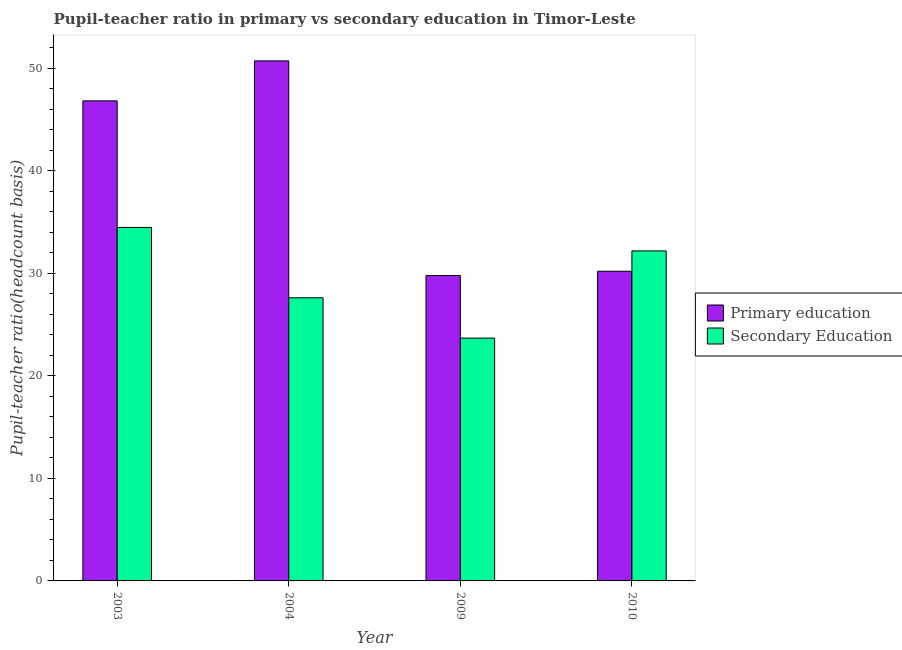How many groups of bars are there?
Ensure brevity in your answer.  4. How many bars are there on the 1st tick from the right?
Provide a short and direct response. 2. What is the pupil-teacher ratio in primary education in 2009?
Your response must be concise. 29.78. Across all years, what is the maximum pupil teacher ratio on secondary education?
Provide a succinct answer. 34.47. Across all years, what is the minimum pupil-teacher ratio in primary education?
Your answer should be compact. 29.78. In which year was the pupil-teacher ratio in primary education maximum?
Make the answer very short. 2004. What is the total pupil teacher ratio on secondary education in the graph?
Offer a very short reply. 117.94. What is the difference between the pupil-teacher ratio in primary education in 2003 and that in 2009?
Offer a very short reply. 17.04. What is the difference between the pupil teacher ratio on secondary education in 2010 and the pupil-teacher ratio in primary education in 2004?
Keep it short and to the point. 4.57. What is the average pupil teacher ratio on secondary education per year?
Offer a very short reply. 29.49. In the year 2004, what is the difference between the pupil-teacher ratio in primary education and pupil teacher ratio on secondary education?
Provide a short and direct response. 0. In how many years, is the pupil-teacher ratio in primary education greater than 24?
Your answer should be very brief. 4. What is the ratio of the pupil-teacher ratio in primary education in 2004 to that in 2010?
Your answer should be very brief. 1.68. Is the pupil teacher ratio on secondary education in 2009 less than that in 2010?
Provide a short and direct response. Yes. Is the difference between the pupil-teacher ratio in primary education in 2004 and 2009 greater than the difference between the pupil teacher ratio on secondary education in 2004 and 2009?
Make the answer very short. No. What is the difference between the highest and the second highest pupil teacher ratio on secondary education?
Make the answer very short. 2.29. What is the difference between the highest and the lowest pupil-teacher ratio in primary education?
Ensure brevity in your answer.  20.94. Is the sum of the pupil teacher ratio on secondary education in 2004 and 2009 greater than the maximum pupil-teacher ratio in primary education across all years?
Provide a succinct answer. Yes. What does the 2nd bar from the left in 2003 represents?
Provide a short and direct response. Secondary Education. What does the 1st bar from the right in 2003 represents?
Make the answer very short. Secondary Education. Are all the bars in the graph horizontal?
Ensure brevity in your answer.  No. How many years are there in the graph?
Your response must be concise. 4. What is the difference between two consecutive major ticks on the Y-axis?
Keep it short and to the point. 10. Does the graph contain any zero values?
Your answer should be very brief. No. Does the graph contain grids?
Give a very brief answer. No. What is the title of the graph?
Provide a short and direct response. Pupil-teacher ratio in primary vs secondary education in Timor-Leste. Does "Male entrants" appear as one of the legend labels in the graph?
Keep it short and to the point. No. What is the label or title of the X-axis?
Your response must be concise. Year. What is the label or title of the Y-axis?
Provide a short and direct response. Pupil-teacher ratio(headcount basis). What is the Pupil-teacher ratio(headcount basis) in Primary education in 2003?
Provide a succinct answer. 46.82. What is the Pupil-teacher ratio(headcount basis) in Secondary Education in 2003?
Provide a succinct answer. 34.47. What is the Pupil-teacher ratio(headcount basis) of Primary education in 2004?
Your response must be concise. 50.71. What is the Pupil-teacher ratio(headcount basis) in Secondary Education in 2004?
Give a very brief answer. 27.61. What is the Pupil-teacher ratio(headcount basis) of Primary education in 2009?
Offer a terse response. 29.78. What is the Pupil-teacher ratio(headcount basis) in Secondary Education in 2009?
Offer a terse response. 23.68. What is the Pupil-teacher ratio(headcount basis) of Primary education in 2010?
Your answer should be very brief. 30.2. What is the Pupil-teacher ratio(headcount basis) of Secondary Education in 2010?
Provide a succinct answer. 32.18. Across all years, what is the maximum Pupil-teacher ratio(headcount basis) of Primary education?
Your answer should be very brief. 50.71. Across all years, what is the maximum Pupil-teacher ratio(headcount basis) in Secondary Education?
Offer a terse response. 34.47. Across all years, what is the minimum Pupil-teacher ratio(headcount basis) of Primary education?
Your answer should be compact. 29.78. Across all years, what is the minimum Pupil-teacher ratio(headcount basis) in Secondary Education?
Your response must be concise. 23.68. What is the total Pupil-teacher ratio(headcount basis) of Primary education in the graph?
Your answer should be very brief. 157.51. What is the total Pupil-teacher ratio(headcount basis) of Secondary Education in the graph?
Keep it short and to the point. 117.94. What is the difference between the Pupil-teacher ratio(headcount basis) of Primary education in 2003 and that in 2004?
Your response must be concise. -3.9. What is the difference between the Pupil-teacher ratio(headcount basis) in Secondary Education in 2003 and that in 2004?
Keep it short and to the point. 6.86. What is the difference between the Pupil-teacher ratio(headcount basis) of Primary education in 2003 and that in 2009?
Keep it short and to the point. 17.04. What is the difference between the Pupil-teacher ratio(headcount basis) of Secondary Education in 2003 and that in 2009?
Offer a very short reply. 10.79. What is the difference between the Pupil-teacher ratio(headcount basis) in Primary education in 2003 and that in 2010?
Offer a terse response. 16.62. What is the difference between the Pupil-teacher ratio(headcount basis) of Secondary Education in 2003 and that in 2010?
Provide a short and direct response. 2.29. What is the difference between the Pupil-teacher ratio(headcount basis) of Primary education in 2004 and that in 2009?
Provide a succinct answer. 20.94. What is the difference between the Pupil-teacher ratio(headcount basis) of Secondary Education in 2004 and that in 2009?
Your answer should be compact. 3.93. What is the difference between the Pupil-teacher ratio(headcount basis) in Primary education in 2004 and that in 2010?
Your response must be concise. 20.52. What is the difference between the Pupil-teacher ratio(headcount basis) in Secondary Education in 2004 and that in 2010?
Make the answer very short. -4.57. What is the difference between the Pupil-teacher ratio(headcount basis) of Primary education in 2009 and that in 2010?
Offer a terse response. -0.42. What is the difference between the Pupil-teacher ratio(headcount basis) in Secondary Education in 2009 and that in 2010?
Provide a succinct answer. -8.51. What is the difference between the Pupil-teacher ratio(headcount basis) in Primary education in 2003 and the Pupil-teacher ratio(headcount basis) in Secondary Education in 2004?
Your response must be concise. 19.2. What is the difference between the Pupil-teacher ratio(headcount basis) in Primary education in 2003 and the Pupil-teacher ratio(headcount basis) in Secondary Education in 2009?
Ensure brevity in your answer.  23.14. What is the difference between the Pupil-teacher ratio(headcount basis) of Primary education in 2003 and the Pupil-teacher ratio(headcount basis) of Secondary Education in 2010?
Make the answer very short. 14.63. What is the difference between the Pupil-teacher ratio(headcount basis) in Primary education in 2004 and the Pupil-teacher ratio(headcount basis) in Secondary Education in 2009?
Offer a very short reply. 27.04. What is the difference between the Pupil-teacher ratio(headcount basis) in Primary education in 2004 and the Pupil-teacher ratio(headcount basis) in Secondary Education in 2010?
Offer a very short reply. 18.53. What is the difference between the Pupil-teacher ratio(headcount basis) in Primary education in 2009 and the Pupil-teacher ratio(headcount basis) in Secondary Education in 2010?
Ensure brevity in your answer.  -2.41. What is the average Pupil-teacher ratio(headcount basis) in Primary education per year?
Offer a very short reply. 39.38. What is the average Pupil-teacher ratio(headcount basis) in Secondary Education per year?
Your answer should be very brief. 29.49. In the year 2003, what is the difference between the Pupil-teacher ratio(headcount basis) of Primary education and Pupil-teacher ratio(headcount basis) of Secondary Education?
Your response must be concise. 12.34. In the year 2004, what is the difference between the Pupil-teacher ratio(headcount basis) in Primary education and Pupil-teacher ratio(headcount basis) in Secondary Education?
Ensure brevity in your answer.  23.1. In the year 2009, what is the difference between the Pupil-teacher ratio(headcount basis) in Primary education and Pupil-teacher ratio(headcount basis) in Secondary Education?
Provide a short and direct response. 6.1. In the year 2010, what is the difference between the Pupil-teacher ratio(headcount basis) in Primary education and Pupil-teacher ratio(headcount basis) in Secondary Education?
Your answer should be compact. -1.98. What is the ratio of the Pupil-teacher ratio(headcount basis) of Primary education in 2003 to that in 2004?
Keep it short and to the point. 0.92. What is the ratio of the Pupil-teacher ratio(headcount basis) in Secondary Education in 2003 to that in 2004?
Your answer should be very brief. 1.25. What is the ratio of the Pupil-teacher ratio(headcount basis) in Primary education in 2003 to that in 2009?
Offer a very short reply. 1.57. What is the ratio of the Pupil-teacher ratio(headcount basis) of Secondary Education in 2003 to that in 2009?
Your answer should be very brief. 1.46. What is the ratio of the Pupil-teacher ratio(headcount basis) of Primary education in 2003 to that in 2010?
Offer a very short reply. 1.55. What is the ratio of the Pupil-teacher ratio(headcount basis) in Secondary Education in 2003 to that in 2010?
Your response must be concise. 1.07. What is the ratio of the Pupil-teacher ratio(headcount basis) in Primary education in 2004 to that in 2009?
Offer a very short reply. 1.7. What is the ratio of the Pupil-teacher ratio(headcount basis) in Secondary Education in 2004 to that in 2009?
Ensure brevity in your answer.  1.17. What is the ratio of the Pupil-teacher ratio(headcount basis) of Primary education in 2004 to that in 2010?
Provide a short and direct response. 1.68. What is the ratio of the Pupil-teacher ratio(headcount basis) of Secondary Education in 2004 to that in 2010?
Keep it short and to the point. 0.86. What is the ratio of the Pupil-teacher ratio(headcount basis) in Primary education in 2009 to that in 2010?
Your answer should be compact. 0.99. What is the ratio of the Pupil-teacher ratio(headcount basis) in Secondary Education in 2009 to that in 2010?
Make the answer very short. 0.74. What is the difference between the highest and the second highest Pupil-teacher ratio(headcount basis) of Primary education?
Provide a short and direct response. 3.9. What is the difference between the highest and the second highest Pupil-teacher ratio(headcount basis) in Secondary Education?
Keep it short and to the point. 2.29. What is the difference between the highest and the lowest Pupil-teacher ratio(headcount basis) of Primary education?
Your answer should be compact. 20.94. What is the difference between the highest and the lowest Pupil-teacher ratio(headcount basis) of Secondary Education?
Your answer should be compact. 10.79. 